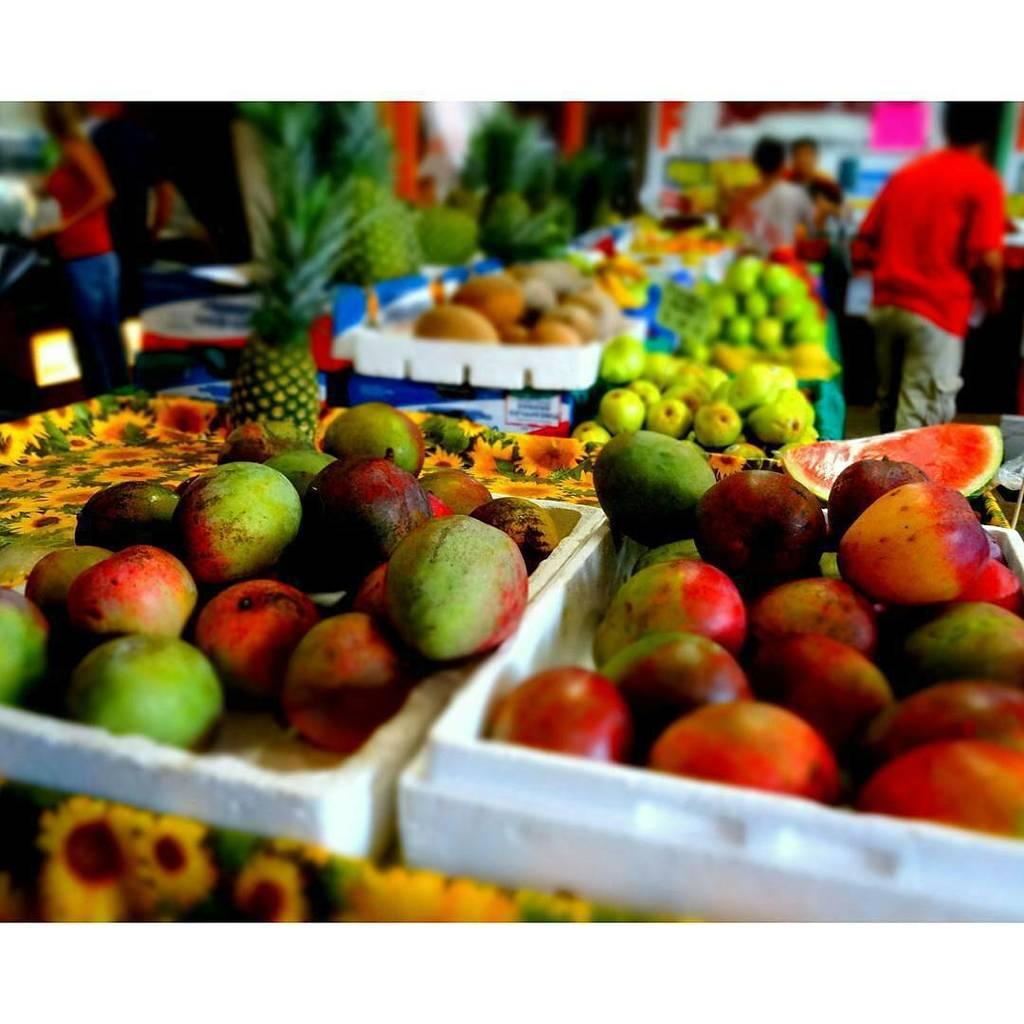Describe this image in one or two sentences. In this image we can see some fruits in a tray and a few people standing on the floor. 